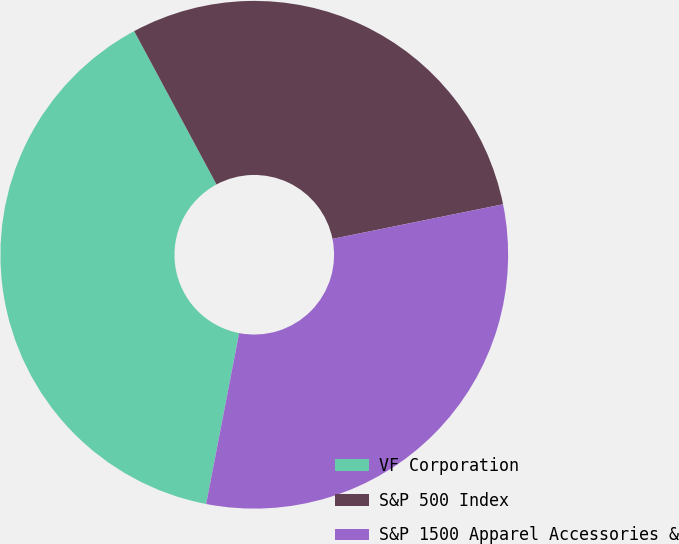Convert chart to OTSL. <chart><loc_0><loc_0><loc_500><loc_500><pie_chart><fcel>VF Corporation<fcel>S&P 500 Index<fcel>S&P 1500 Apparel Accessories &<nl><fcel>39.12%<fcel>29.66%<fcel>31.22%<nl></chart> 